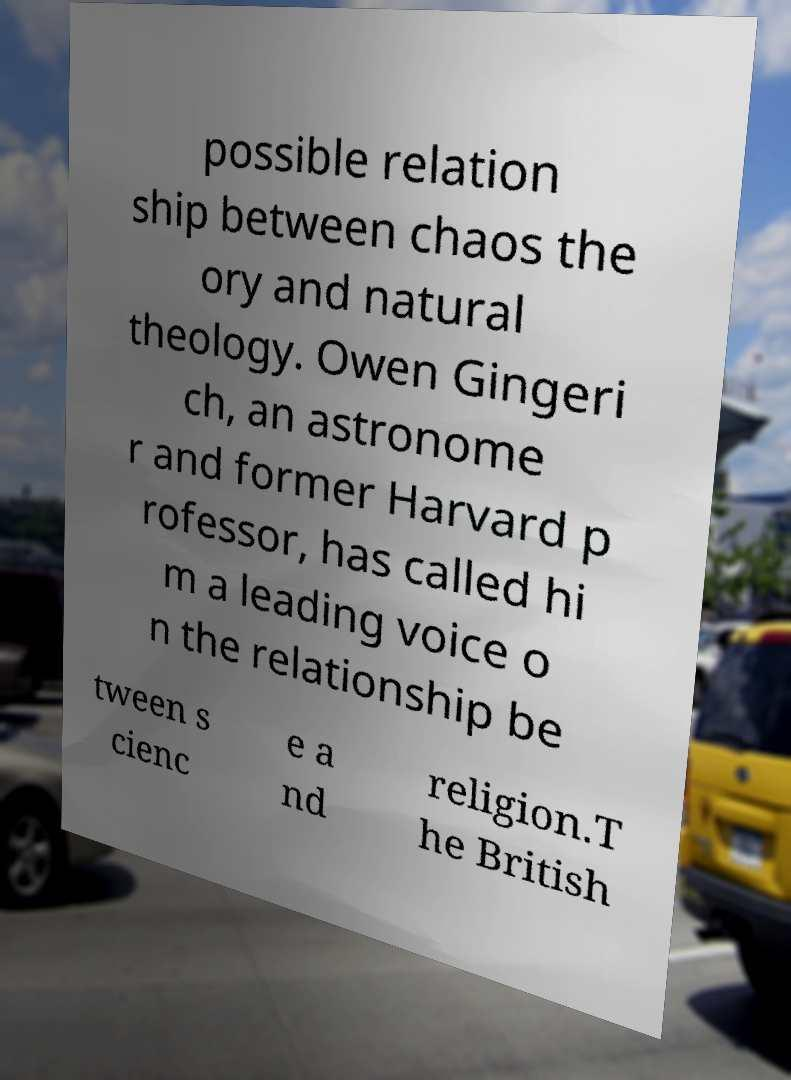Please read and relay the text visible in this image. What does it say? possible relation ship between chaos the ory and natural theology. Owen Gingeri ch, an astronome r and former Harvard p rofessor, has called hi m a leading voice o n the relationship be tween s cienc e a nd religion.T he British 